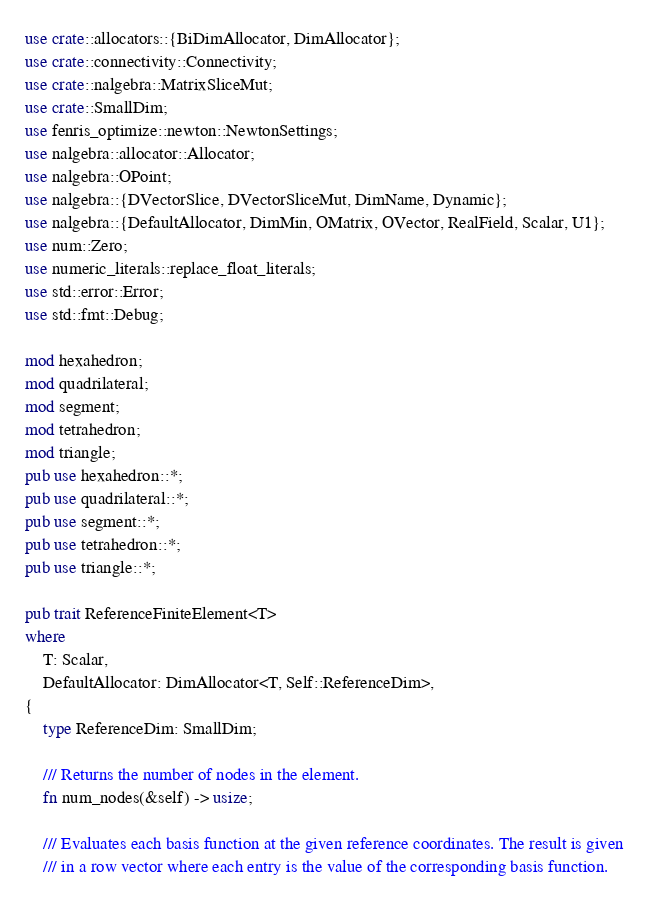Convert code to text. <code><loc_0><loc_0><loc_500><loc_500><_Rust_>use crate::allocators::{BiDimAllocator, DimAllocator};
use crate::connectivity::Connectivity;
use crate::nalgebra::MatrixSliceMut;
use crate::SmallDim;
use fenris_optimize::newton::NewtonSettings;
use nalgebra::allocator::Allocator;
use nalgebra::OPoint;
use nalgebra::{DVectorSlice, DVectorSliceMut, DimName, Dynamic};
use nalgebra::{DefaultAllocator, DimMin, OMatrix, OVector, RealField, Scalar, U1};
use num::Zero;
use numeric_literals::replace_float_literals;
use std::error::Error;
use std::fmt::Debug;

mod hexahedron;
mod quadrilateral;
mod segment;
mod tetrahedron;
mod triangle;
pub use hexahedron::*;
pub use quadrilateral::*;
pub use segment::*;
pub use tetrahedron::*;
pub use triangle::*;

pub trait ReferenceFiniteElement<T>
where
    T: Scalar,
    DefaultAllocator: DimAllocator<T, Self::ReferenceDim>,
{
    type ReferenceDim: SmallDim;

    /// Returns the number of nodes in the element.
    fn num_nodes(&self) -> usize;

    /// Evaluates each basis function at the given reference coordinates. The result is given
    /// in a row vector where each entry is the value of the corresponding basis function.</code> 